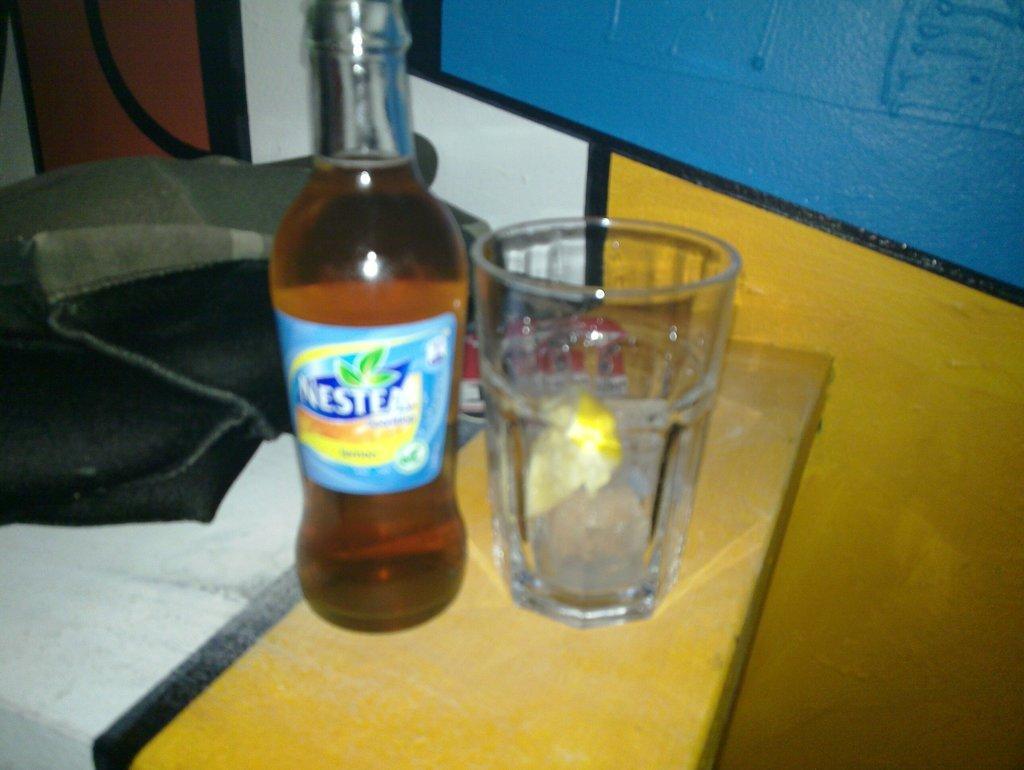In one or two sentences, can you explain what this image depicts? In this picture we can see a bottle with drink in it and glass with water in it this are placed on table and bedside to this we have bag and in the background we can see wall with yellow, blue and white color painting. 